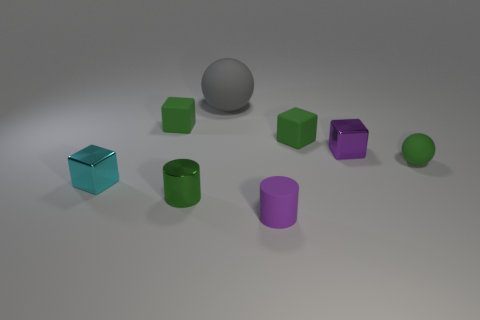Subtract all tiny purple cubes. How many cubes are left? 3 Subtract all green cubes. How many cubes are left? 2 Subtract 1 cylinders. How many cylinders are left? 1 Add 1 tiny green cylinders. How many objects exist? 9 Subtract all cyan cylinders. Subtract all green blocks. How many cylinders are left? 2 Subtract all large matte things. Subtract all tiny purple cubes. How many objects are left? 6 Add 7 gray rubber spheres. How many gray rubber spheres are left? 8 Add 3 tiny rubber cylinders. How many tiny rubber cylinders exist? 4 Subtract 1 cyan cubes. How many objects are left? 7 Subtract all cylinders. How many objects are left? 6 